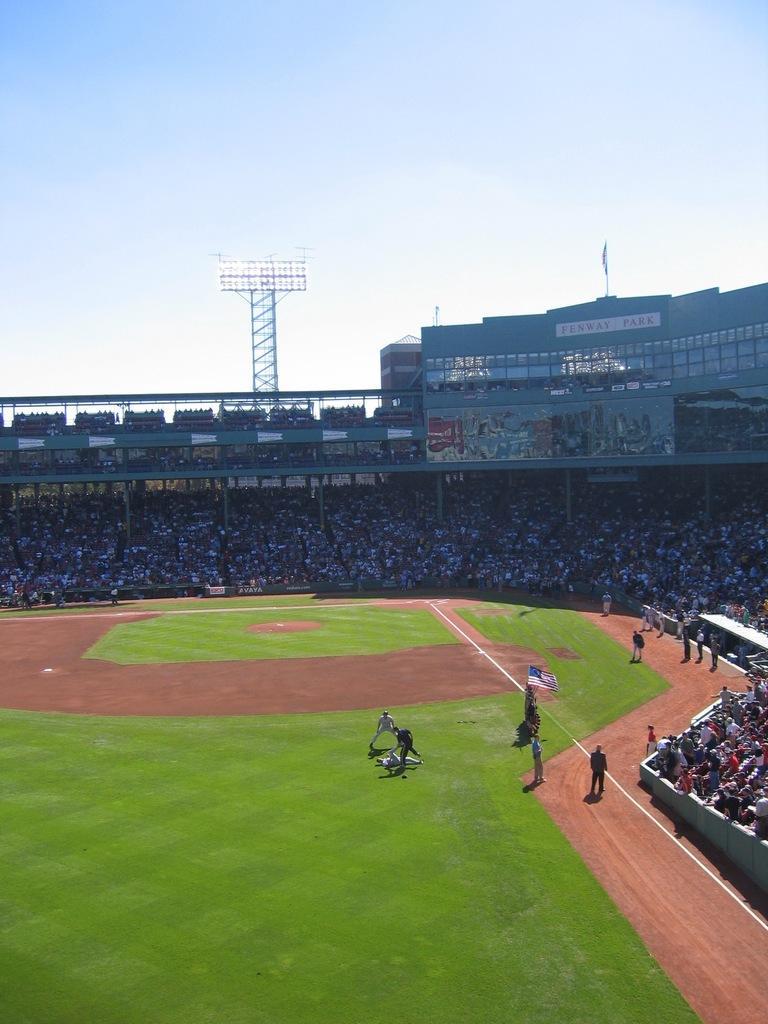Describe this image in one or two sentences. In this image I can see a stadium and people are sitting and on the ground there are many grasses. 